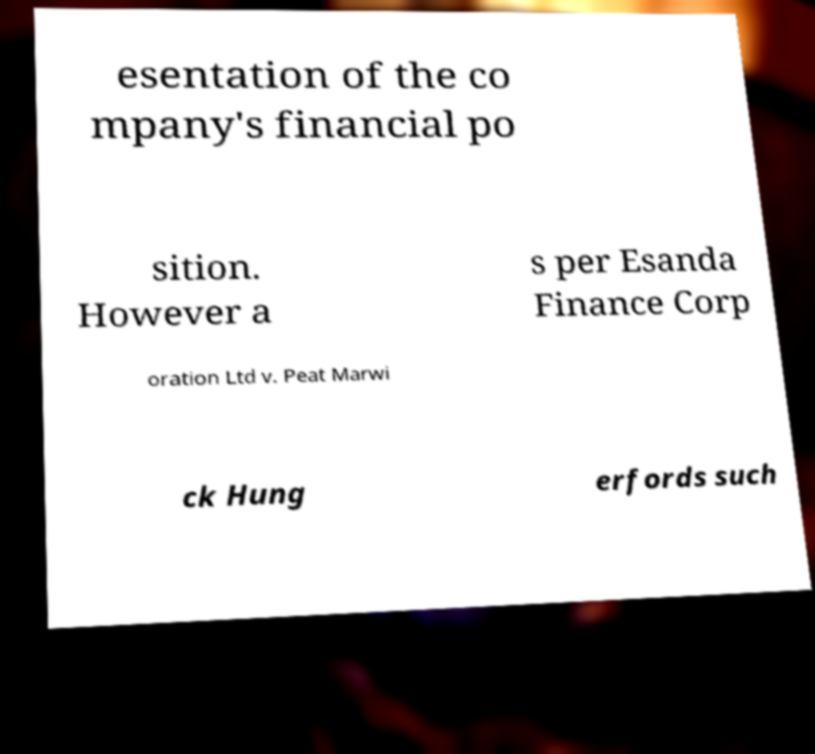I need the written content from this picture converted into text. Can you do that? esentation of the co mpany's financial po sition. However a s per Esanda Finance Corp oration Ltd v. Peat Marwi ck Hung erfords such 